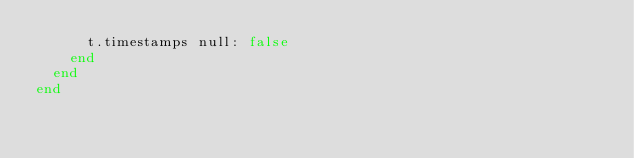Convert code to text. <code><loc_0><loc_0><loc_500><loc_500><_Ruby_>      t.timestamps null: false
    end
  end
end
</code> 